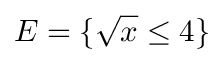<formula> <loc_0><loc_0><loc_500><loc_500>E = \{ { \sqrt { x } } \leq 4 \}</formula> 